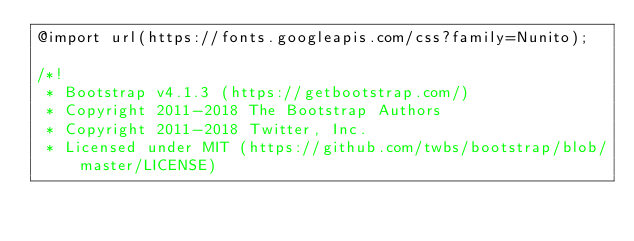Convert code to text. <code><loc_0><loc_0><loc_500><loc_500><_CSS_>@import url(https://fonts.googleapis.com/css?family=Nunito);

/*!
 * Bootstrap v4.1.3 (https://getbootstrap.com/)
 * Copyright 2011-2018 The Bootstrap Authors
 * Copyright 2011-2018 Twitter, Inc.
 * Licensed under MIT (https://github.com/twbs/bootstrap/blob/master/LICENSE)</code> 